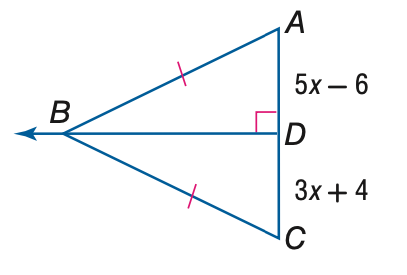Answer the mathemtical geometry problem and directly provide the correct option letter.
Question: Find the measure of A C.
Choices: A: 19 B: 30 C: 38 D: 76 C 